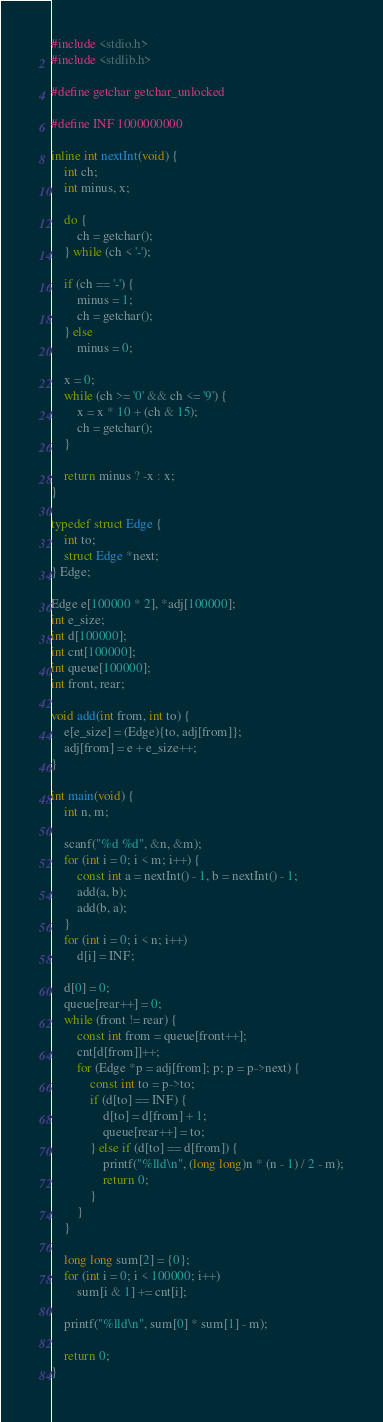<code> <loc_0><loc_0><loc_500><loc_500><_C_>#include <stdio.h>
#include <stdlib.h>

#define getchar getchar_unlocked

#define INF 1000000000

inline int nextInt(void) {
	int ch;
	int minus, x;

	do {
		ch = getchar();
	} while (ch < '-');

	if (ch == '-') {
		minus = 1;
		ch = getchar();
	} else
		minus = 0;

	x = 0;
	while (ch >= '0' && ch <= '9') {
		x = x * 10 + (ch & 15);
		ch = getchar();
	}

	return minus ? -x : x;
}

typedef struct Edge {
	int to;
	struct Edge *next;
} Edge;

Edge e[100000 * 2], *adj[100000];
int e_size;
int d[100000];
int cnt[100000];
int queue[100000];
int front, rear;

void add(int from, int to) {
	e[e_size] = (Edge){to, adj[from]};
	adj[from] = e + e_size++;
}

int main(void) {
	int n, m;

	scanf("%d %d", &n, &m);
	for (int i = 0; i < m; i++) {
		const int a = nextInt() - 1, b = nextInt() - 1;
		add(a, b);
		add(b, a);
	}
	for (int i = 0; i < n; i++)
		d[i] = INF;

	d[0] = 0;
	queue[rear++] = 0;
	while (front != rear) {
		const int from = queue[front++];
		cnt[d[from]]++;
		for (Edge *p = adj[from]; p; p = p->next) {
			const int to = p->to;
			if (d[to] == INF) {
				d[to] = d[from] + 1;
				queue[rear++] = to;
			} else if (d[to] == d[from]) {
				printf("%lld\n", (long long)n * (n - 1) / 2 - m);
				return 0;
			}
		}
	}

	long long sum[2] = {0};
	for (int i = 0; i < 100000; i++)
		sum[i & 1] += cnt[i];

	printf("%lld\n", sum[0] * sum[1] - m);

	return 0;
}
</code> 